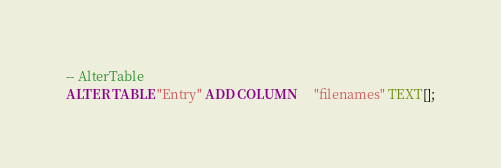Convert code to text. <code><loc_0><loc_0><loc_500><loc_500><_SQL_>-- AlterTable
ALTER TABLE "Entry" ADD COLUMN     "filenames" TEXT[];
</code> 